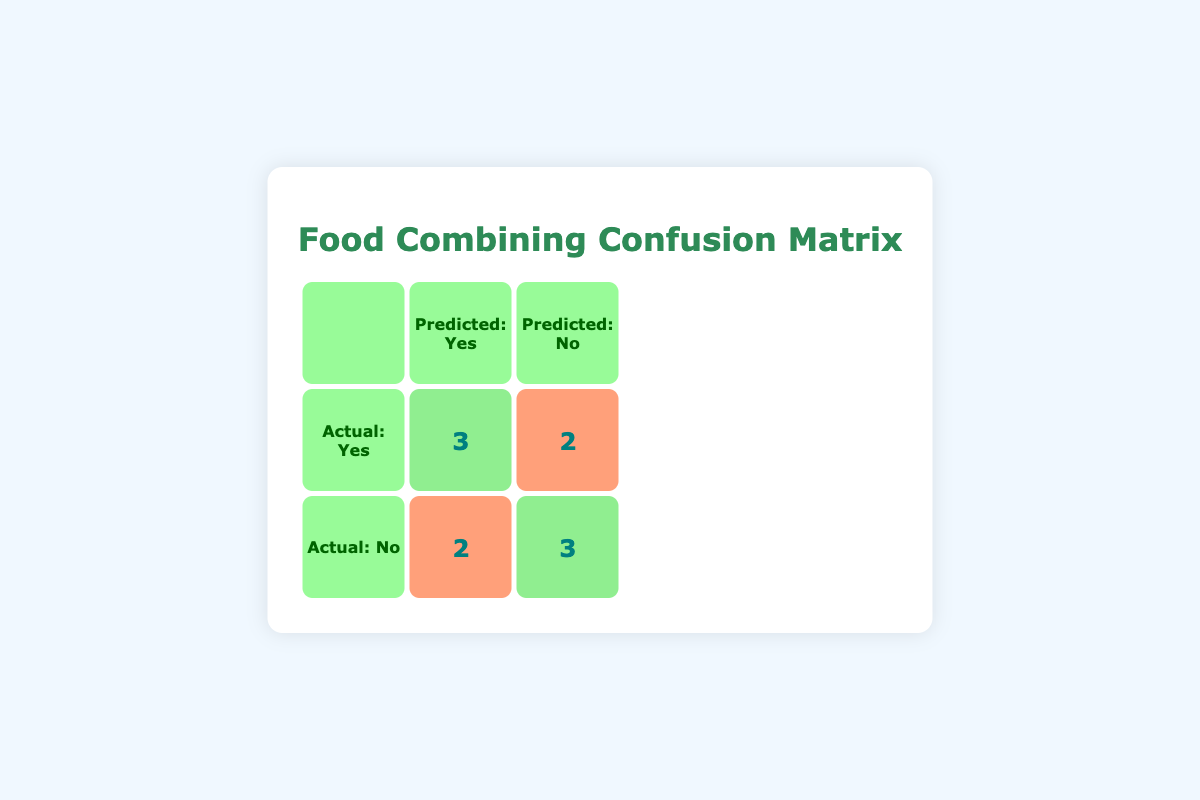What is the number of true positives in the confusion matrix? The true positives are represented in the cell at the intersection of "Actual: Yes" and "Predicted: Yes." From the table, this value is 3.
Answer: 3 What is the total number of patients in the study? To find the total number of patients, I can sum the true positives, false negatives, false positives, and true negatives: 3 (TP) + 2 (FN) + 2 (FP) + 3 (TN) = 10.
Answer: 10 How many patients reported a reduction in bloating symptoms after food combining? The reduction in bloating symptoms corresponds to the total of true positives and false negatives: 3 (TP) + 2 (FN) = 5 patients.
Answer: 5 What is the number of false negatives in the confusion matrix? The false negatives are found in the cell at the intersection of "Actual: Yes" and "Predicted: No." According to the table, this value is 2.
Answer: 2 Is it true that more patients reported reduced bloating symptoms after food combining than those who did not? To determine this, compare the number of true positives (3) with the number of true negatives (3). Both values are equal, indicating that it is not true; they are balanced.
Answer: No What is the percentage of patients that experienced reduced bloating symptoms when using food combining techniques? To find this percentage, divide the number of patients who experienced reduction (5) by the total number of patients (10) and multiply by 100: (5/10)*100 = 50%.
Answer: 50% What is the number of patients whose bloating symptoms did not reduce despite food combining? This number comes from the false negatives plus the number of patients who did not combine their food but still report symptoms: 2 (FN) + 2 (FP) = 4 patients.
Answer: 4 What is the accuracy of the food combining techniques in this study? Accuracy is calculated as (True Positives + True Negatives) / Total Patients = (3 + 3) / 10 = 0.6 or 60%.
Answer: 60% How many patients did not reduce bloating symptoms and did not practice food combining? This corresponds to the true negatives in the cell where "Actual: No" and "Predicted: No" intersect. From the table, this value is 3.
Answer: 3 